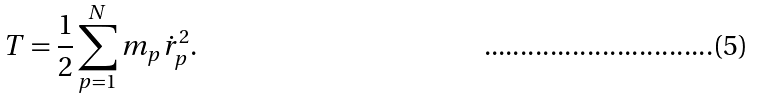<formula> <loc_0><loc_0><loc_500><loc_500>T = \frac { 1 } { 2 } \sum ^ { N } _ { p = 1 } m _ { p } \dot { r } ^ { 2 } _ { p } .</formula> 